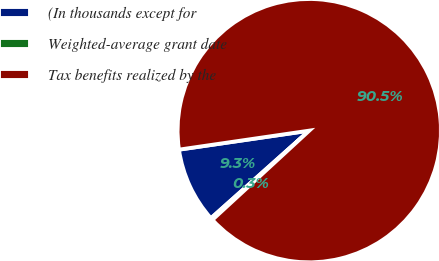<chart> <loc_0><loc_0><loc_500><loc_500><pie_chart><fcel>(In thousands except for<fcel>Weighted-average grant date<fcel>Tax benefits realized by the<nl><fcel>9.28%<fcel>0.26%<fcel>90.47%<nl></chart> 